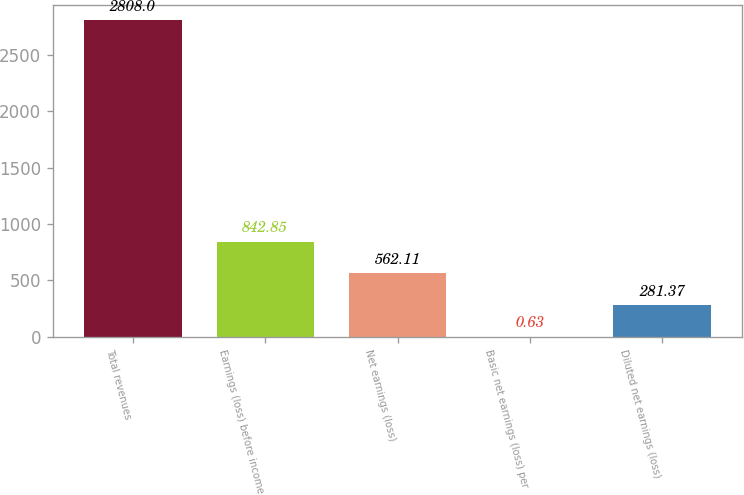Convert chart. <chart><loc_0><loc_0><loc_500><loc_500><bar_chart><fcel>Total revenues<fcel>Earnings (loss) before income<fcel>Net earnings (loss)<fcel>Basic net earnings (loss) per<fcel>Diluted net earnings (loss)<nl><fcel>2808<fcel>842.85<fcel>562.11<fcel>0.63<fcel>281.37<nl></chart> 